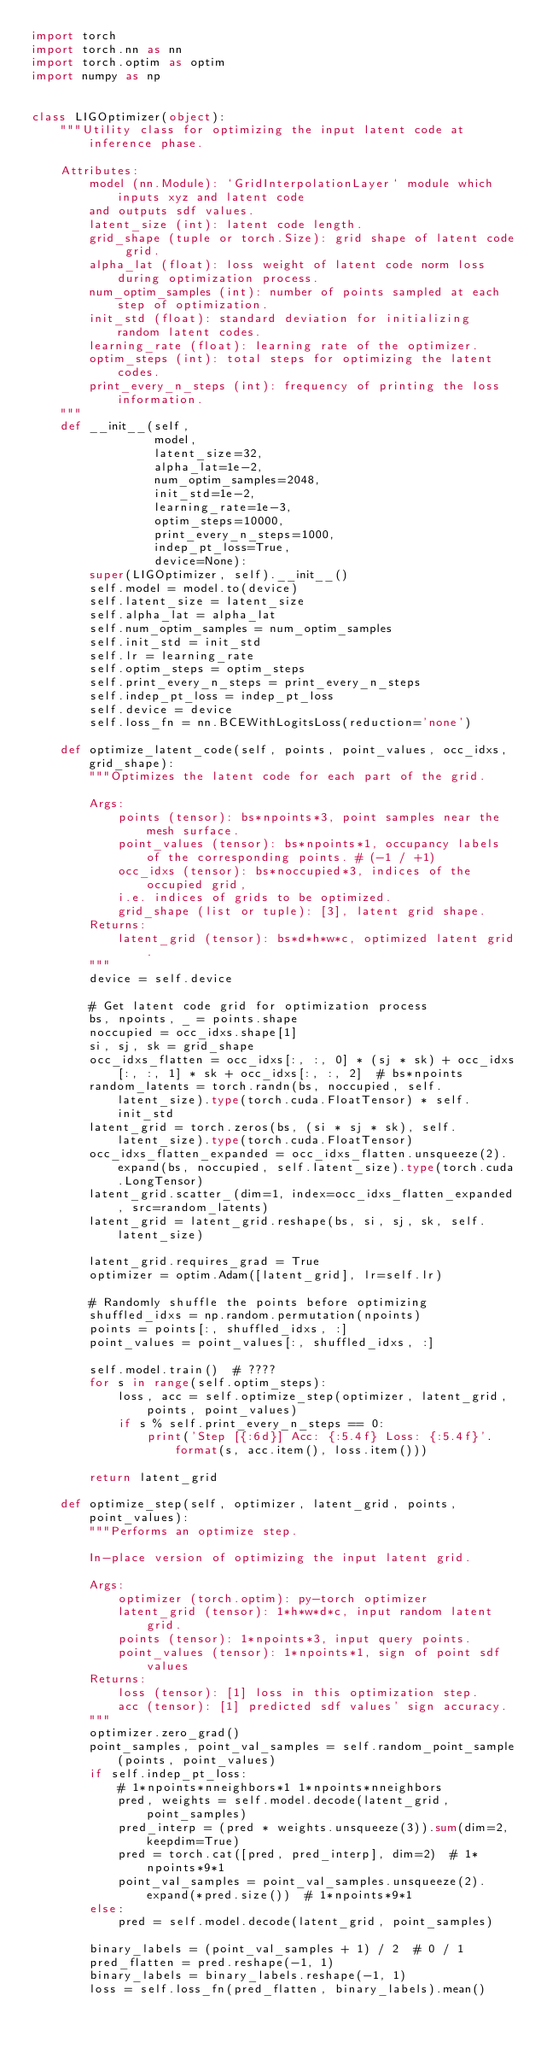<code> <loc_0><loc_0><loc_500><loc_500><_Python_>import torch
import torch.nn as nn
import torch.optim as optim
import numpy as np


class LIGOptimizer(object):
    """Utility class for optimizing the input latent code at inference phase.

    Attributes:
        model (nn.Module): `GridInterpolationLayer` module which inputs xyz and latent code
        and outputs sdf values.
        latent_size (int): latent code length.
        grid_shape (tuple or torch.Size): grid shape of latent code grid.
        alpha_lat (float): loss weight of latent code norm loss during optimization process.
        num_optim_samples (int): number of points sampled at each step of optimization.
        init_std (float): standard deviation for initializing random latent codes.
        learning_rate (float): learning rate of the optimizer.
        optim_steps (int): total steps for optimizing the latent codes.
        print_every_n_steps (int): frequency of printing the loss information.
    """
    def __init__(self,
                 model,
                 latent_size=32,
                 alpha_lat=1e-2,
                 num_optim_samples=2048,
                 init_std=1e-2,
                 learning_rate=1e-3,
                 optim_steps=10000,
                 print_every_n_steps=1000,
                 indep_pt_loss=True,
                 device=None):
        super(LIGOptimizer, self).__init__()
        self.model = model.to(device)
        self.latent_size = latent_size
        self.alpha_lat = alpha_lat
        self.num_optim_samples = num_optim_samples
        self.init_std = init_std
        self.lr = learning_rate
        self.optim_steps = optim_steps
        self.print_every_n_steps = print_every_n_steps
        self.indep_pt_loss = indep_pt_loss
        self.device = device
        self.loss_fn = nn.BCEWithLogitsLoss(reduction='none')

    def optimize_latent_code(self, points, point_values, occ_idxs, grid_shape):
        """Optimizes the latent code for each part of the grid.

        Args:
            points (tensor): bs*npoints*3, point samples near the mesh surface.
            point_values (tensor): bs*npoints*1, occupancy labels of the corresponding points. # (-1 / +1)
            occ_idxs (tensor): bs*noccupied*3, indices of the occupied grid,
            i.e. indices of grids to be optimized.
            grid_shape (list or tuple): [3], latent grid shape.
        Returns:
            latent_grid (tensor): bs*d*h*w*c, optimized latent grid.
        """
        device = self.device

        # Get latent code grid for optimization process
        bs, npoints, _ = points.shape
        noccupied = occ_idxs.shape[1]
        si, sj, sk = grid_shape
        occ_idxs_flatten = occ_idxs[:, :, 0] * (sj * sk) + occ_idxs[:, :, 1] * sk + occ_idxs[:, :, 2]  # bs*npoints
        random_latents = torch.randn(bs, noccupied, self.latent_size).type(torch.cuda.FloatTensor) * self.init_std
        latent_grid = torch.zeros(bs, (si * sj * sk), self.latent_size).type(torch.cuda.FloatTensor)
        occ_idxs_flatten_expanded = occ_idxs_flatten.unsqueeze(2).expand(bs, noccupied, self.latent_size).type(torch.cuda.LongTensor)
        latent_grid.scatter_(dim=1, index=occ_idxs_flatten_expanded, src=random_latents)
        latent_grid = latent_grid.reshape(bs, si, sj, sk, self.latent_size)

        latent_grid.requires_grad = True
        optimizer = optim.Adam([latent_grid], lr=self.lr)

        # Randomly shuffle the points before optimizing
        shuffled_idxs = np.random.permutation(npoints)
        points = points[:, shuffled_idxs, :]
        point_values = point_values[:, shuffled_idxs, :]

        self.model.train()  # ????
        for s in range(self.optim_steps):
            loss, acc = self.optimize_step(optimizer, latent_grid, points, point_values)
            if s % self.print_every_n_steps == 0:
                print('Step [{:6d}] Acc: {:5.4f} Loss: {:5.4f}'.format(s, acc.item(), loss.item()))

        return latent_grid

    def optimize_step(self, optimizer, latent_grid, points, point_values):
        """Performs an optimize step.

        In-place version of optimizing the input latent grid.

        Args:
            optimizer (torch.optim): py-torch optimizer
            latent_grid (tensor): 1*h*w*d*c, input random latent grid.
            points (tensor): 1*npoints*3, input query points.
            point_values (tensor): 1*npoints*1, sign of point sdf values
        Returns:
            loss (tensor): [1] loss in this optimization step.
            acc (tensor): [1] predicted sdf values' sign accuracy.
        """
        optimizer.zero_grad()
        point_samples, point_val_samples = self.random_point_sample(points, point_values)
        if self.indep_pt_loss:
            # 1*npoints*nneighbors*1 1*npoints*nneighbors
            pred, weights = self.model.decode(latent_grid, point_samples)
            pred_interp = (pred * weights.unsqueeze(3)).sum(dim=2, keepdim=True)
            pred = torch.cat([pred, pred_interp], dim=2)  # 1*npoints*9*1
            point_val_samples = point_val_samples.unsqueeze(2).expand(*pred.size())  # 1*npoints*9*1
        else:
            pred = self.model.decode(latent_grid, point_samples)

        binary_labels = (point_val_samples + 1) / 2  # 0 / 1
        pred_flatten = pred.reshape(-1, 1)
        binary_labels = binary_labels.reshape(-1, 1)
        loss = self.loss_fn(pred_flatten, binary_labels).mean()</code> 